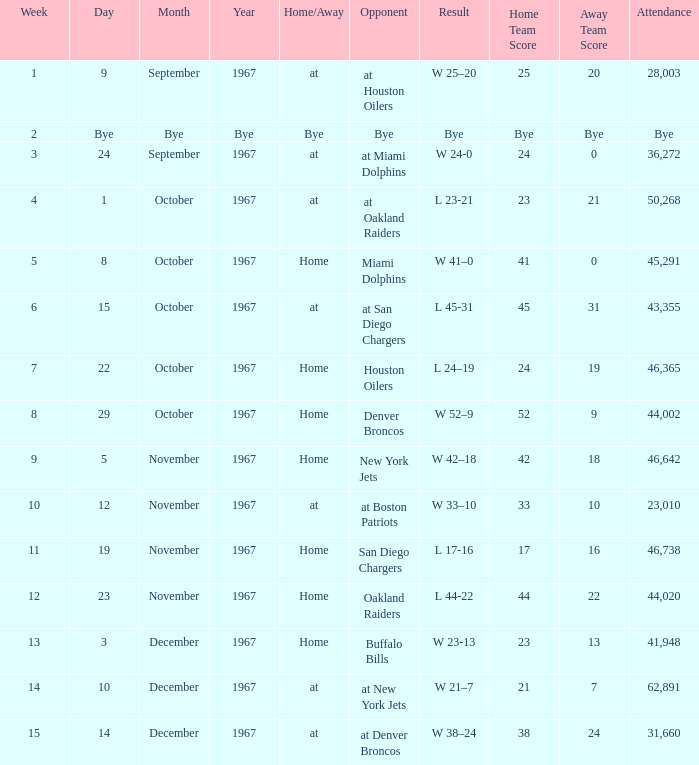Who was the opponent after week 9 with an attendance of 44,020? Oakland Raiders. 